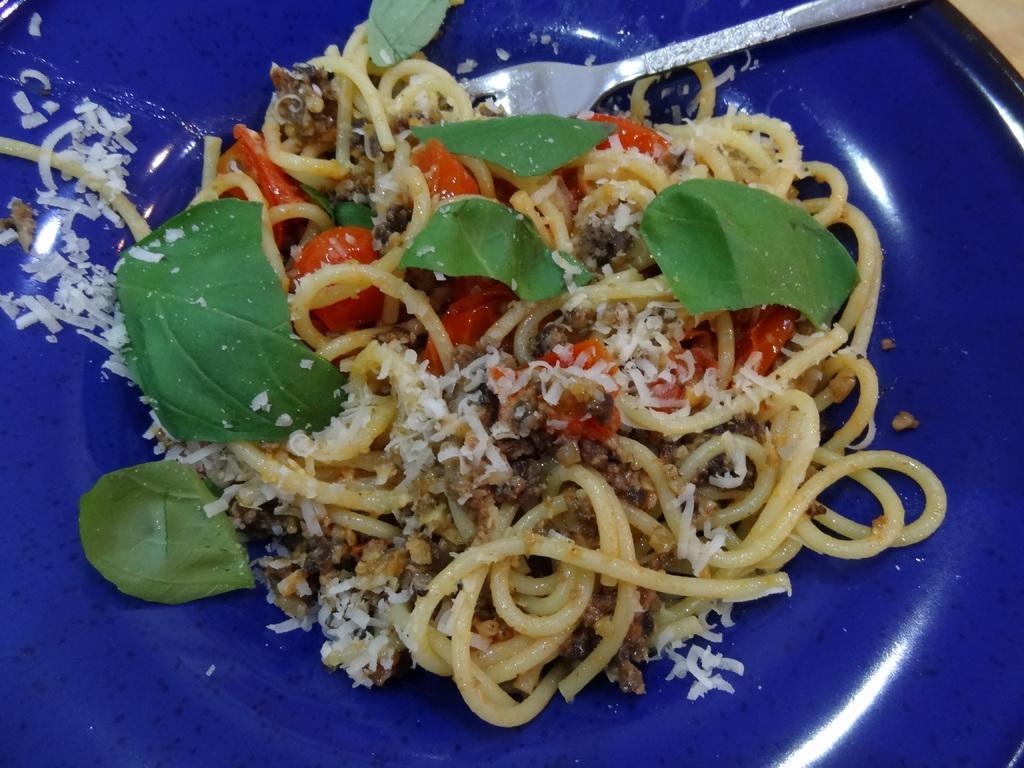Describe this image in one or two sentences. In this picture we can see noodles, fork, few leaves and other food in the plate. 